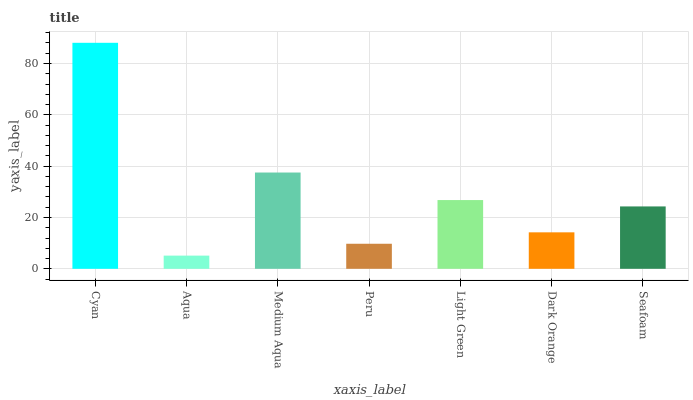Is Aqua the minimum?
Answer yes or no. Yes. Is Cyan the maximum?
Answer yes or no. Yes. Is Medium Aqua the minimum?
Answer yes or no. No. Is Medium Aqua the maximum?
Answer yes or no. No. Is Medium Aqua greater than Aqua?
Answer yes or no. Yes. Is Aqua less than Medium Aqua?
Answer yes or no. Yes. Is Aqua greater than Medium Aqua?
Answer yes or no. No. Is Medium Aqua less than Aqua?
Answer yes or no. No. Is Seafoam the high median?
Answer yes or no. Yes. Is Seafoam the low median?
Answer yes or no. Yes. Is Peru the high median?
Answer yes or no. No. Is Light Green the low median?
Answer yes or no. No. 